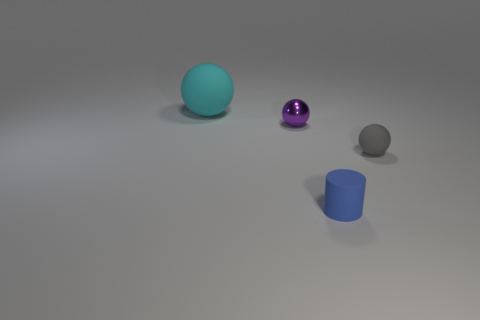Can you describe the sizes and colors of the objects in the image? In the image, there is a cyan-colored sphere, a purple, shiny sphere, a matte gray sphere, and a blue cylinder. The cyan sphere is the largest object, followed by the purple and gray spheres which are smaller, and the blue cylinder appears to be the smallest object in terms of height. 